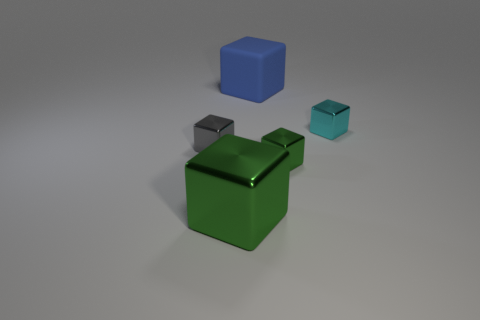Subtract 1 blocks. How many blocks are left? 4 Subtract all rubber cubes. How many cubes are left? 4 Subtract all cyan cubes. How many cubes are left? 4 Subtract all yellow cubes. Subtract all yellow spheres. How many cubes are left? 5 Add 4 gray objects. How many objects exist? 9 Subtract 0 red cubes. How many objects are left? 5 Subtract all big green blocks. Subtract all small gray cubes. How many objects are left? 3 Add 5 small things. How many small things are left? 8 Add 5 large cyan things. How many large cyan things exist? 5 